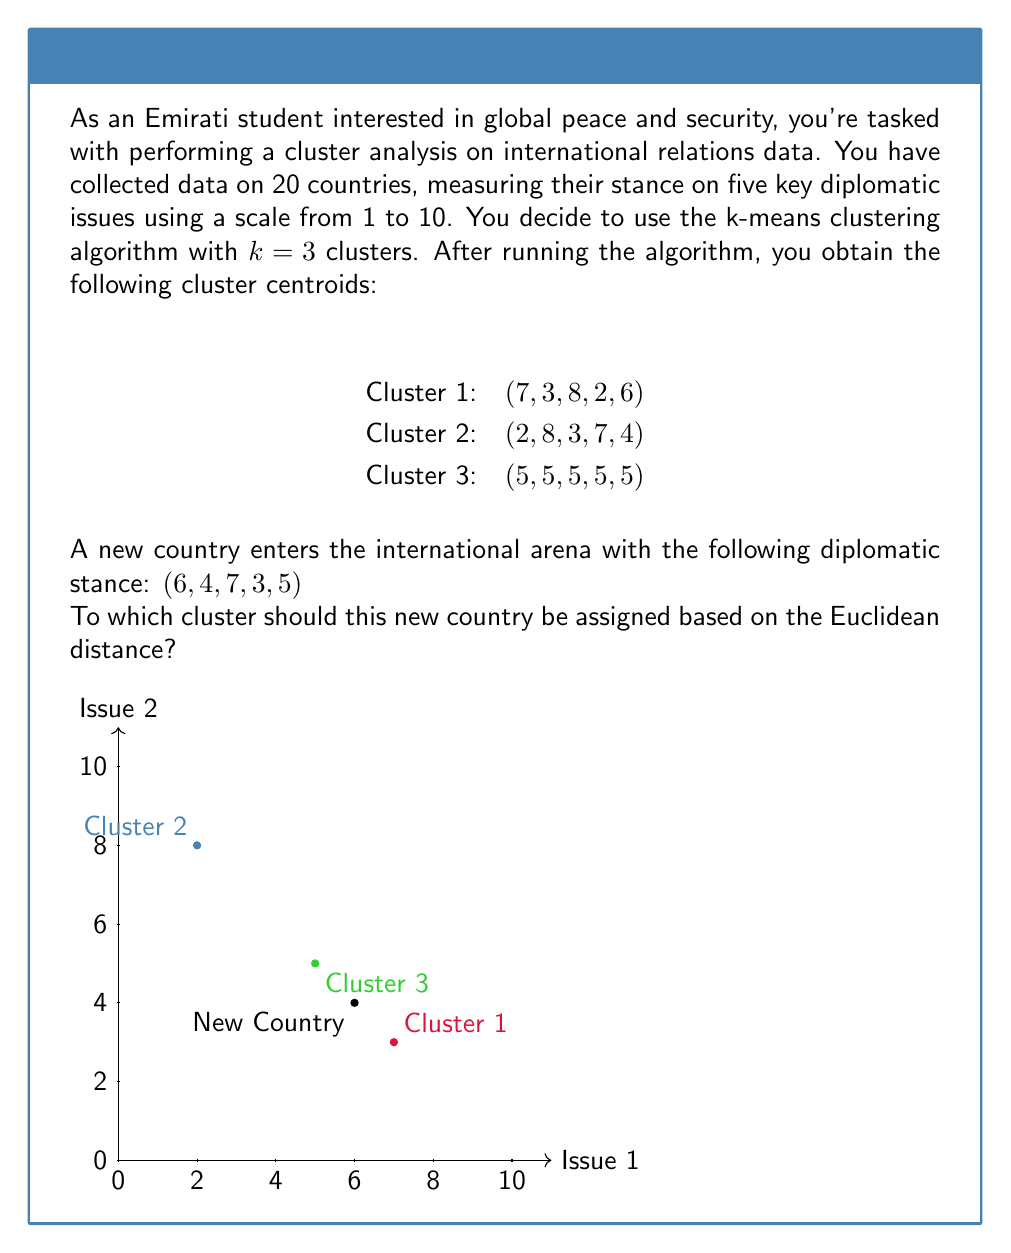Provide a solution to this math problem. To determine which cluster the new country should be assigned to, we need to calculate the Euclidean distance between the new country's stance and each cluster centroid, then choose the cluster with the smallest distance.

The Euclidean distance in 5-dimensional space is given by:

$$d = \sqrt{(x_1-c_1)^2 + (x_2-c_2)^2 + (x_3-c_3)^2 + (x_4-c_4)^2 + (x_5-c_5)^2}$$

Where $(x_1, x_2, x_3, x_4, x_5)$ is the new country's stance and $(c_1, c_2, c_3, c_4, c_5)$ is the cluster centroid.

Step 1: Calculate distance to Cluster 1
$$d_1 = \sqrt{(6-7)^2 + (4-3)^2 + (7-8)^2 + (3-2)^2 + (5-6)^2}$$
$$d_1 = \sqrt{1 + 1 + 1 + 1 + 1} = \sqrt{5} \approx 2.24$$

Step 2: Calculate distance to Cluster 2
$$d_2 = \sqrt{(6-2)^2 + (4-8)^2 + (7-3)^2 + (3-7)^2 + (5-4)^2}$$
$$d_2 = \sqrt{16 + 16 + 16 + 16 + 1} = \sqrt{65} \approx 8.06$$

Step 3: Calculate distance to Cluster 3
$$d_3 = \sqrt{(6-5)^2 + (4-5)^2 + (7-5)^2 + (3-5)^2 + (5-5)^2}$$
$$d_3 = \sqrt{1 + 1 + 4 + 4 + 0} = \sqrt{10} \approx 3.16$$

Step 4: Compare distances
The smallest distance is $d_1 \approx 2.24$, corresponding to Cluster 1.
Answer: Cluster 1 